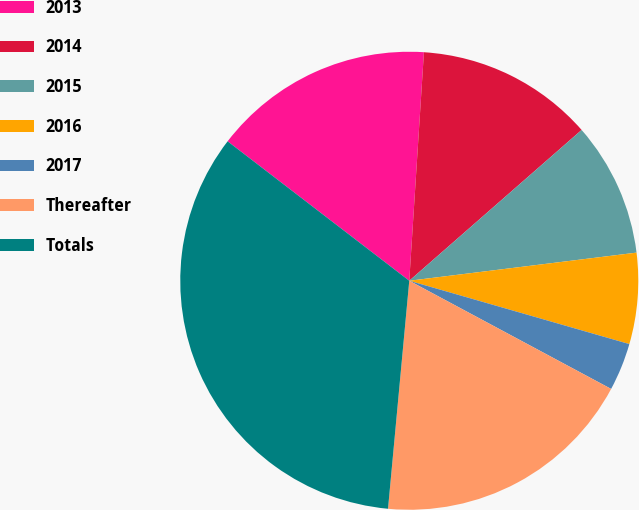Convert chart. <chart><loc_0><loc_0><loc_500><loc_500><pie_chart><fcel>2013<fcel>2014<fcel>2015<fcel>2016<fcel>2017<fcel>Thereafter<fcel>Totals<nl><fcel>15.6%<fcel>12.54%<fcel>9.48%<fcel>6.42%<fcel>3.37%<fcel>18.65%<fcel>33.94%<nl></chart> 